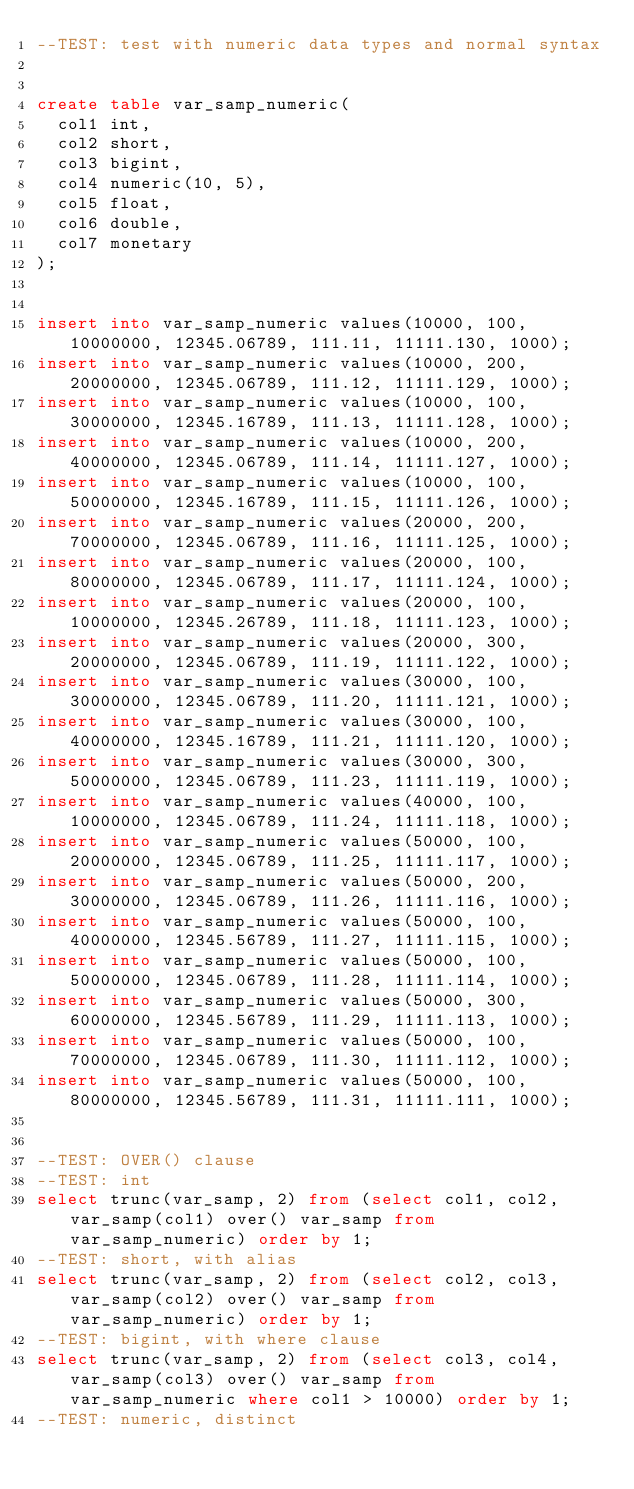<code> <loc_0><loc_0><loc_500><loc_500><_SQL_>--TEST: test with numeric data types and normal syntax


create table var_samp_numeric(
	col1 int,
	col2 short, 
	col3 bigint,
	col4 numeric(10, 5),
	col5 float,
	col6 double,
	col7 monetary
);


insert into var_samp_numeric values(10000, 100, 10000000, 12345.06789, 111.11, 11111.130, 1000);
insert into var_samp_numeric values(10000, 200, 20000000, 12345.06789, 111.12, 11111.129, 1000);
insert into var_samp_numeric values(10000, 100, 30000000, 12345.16789, 111.13, 11111.128, 1000);
insert into var_samp_numeric values(10000, 200, 40000000, 12345.06789, 111.14, 11111.127, 1000);
insert into var_samp_numeric values(10000, 100, 50000000, 12345.16789, 111.15, 11111.126, 1000);
insert into var_samp_numeric values(20000, 200, 70000000, 12345.06789, 111.16, 11111.125, 1000);
insert into var_samp_numeric values(20000, 100, 80000000, 12345.06789, 111.17, 11111.124, 1000);
insert into var_samp_numeric values(20000, 100, 10000000, 12345.26789, 111.18, 11111.123, 1000);
insert into var_samp_numeric values(20000, 300, 20000000, 12345.06789, 111.19, 11111.122, 1000);
insert into var_samp_numeric values(30000, 100, 30000000, 12345.06789, 111.20, 11111.121, 1000);
insert into var_samp_numeric values(30000, 100, 40000000, 12345.16789, 111.21, 11111.120, 1000);
insert into var_samp_numeric values(30000, 300, 50000000, 12345.06789, 111.23, 11111.119, 1000);
insert into var_samp_numeric values(40000, 100, 10000000, 12345.06789, 111.24, 11111.118, 1000);
insert into var_samp_numeric values(50000, 100, 20000000, 12345.06789, 111.25, 11111.117, 1000);
insert into var_samp_numeric values(50000, 200, 30000000, 12345.06789, 111.26, 11111.116, 1000);
insert into var_samp_numeric values(50000, 100, 40000000, 12345.56789, 111.27, 11111.115, 1000);
insert into var_samp_numeric values(50000, 100, 50000000, 12345.06789, 111.28, 11111.114, 1000);
insert into var_samp_numeric values(50000, 300, 60000000, 12345.56789, 111.29, 11111.113, 1000);
insert into var_samp_numeric values(50000, 100, 70000000, 12345.06789, 111.30, 11111.112, 1000);
insert into var_samp_numeric values(50000, 100, 80000000, 12345.56789, 111.31, 11111.111, 1000);


--TEST: OVER() clause
--TEST: int 
select trunc(var_samp, 2) from (select col1, col2, var_samp(col1) over() var_samp from var_samp_numeric) order by 1;
--TEST: short, with alias
select trunc(var_samp, 2) from (select col2, col3, var_samp(col2) over() var_samp from var_samp_numeric) order by 1;
--TEST: bigint, with where clause
select trunc(var_samp, 2) from (select col3, col4, var_samp(col3) over() var_samp from var_samp_numeric where col1 > 10000) order by 1;
--TEST: numeric, distinct</code> 